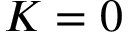<formula> <loc_0><loc_0><loc_500><loc_500>K = 0</formula> 